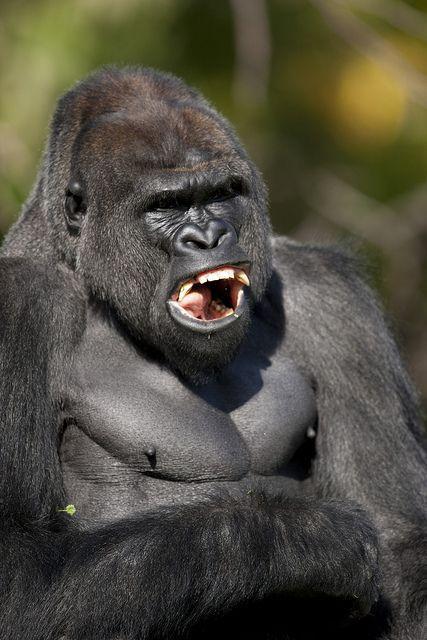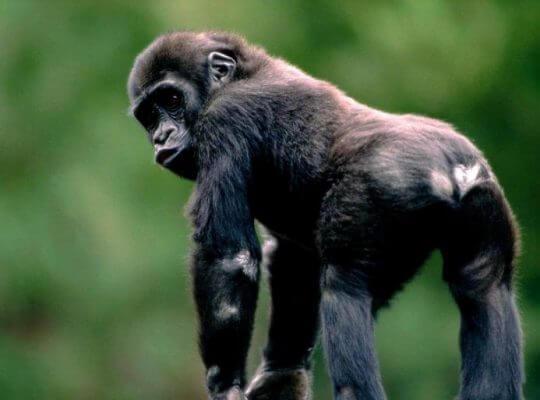The first image is the image on the left, the second image is the image on the right. Analyze the images presented: Is the assertion "The ape in the image on the left is baring its teeth." valid? Answer yes or no. Yes. The first image is the image on the left, the second image is the image on the right. Evaluate the accuracy of this statement regarding the images: "One image shows one ape, which is in a rear-facing on-all-fours pose, and the other image shows a gorilla baring its fangs.". Is it true? Answer yes or no. Yes. 